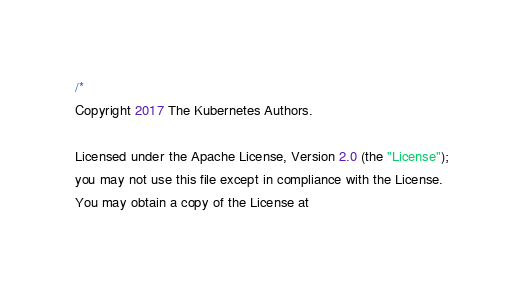<code> <loc_0><loc_0><loc_500><loc_500><_Go_>/*
Copyright 2017 The Kubernetes Authors.

Licensed under the Apache License, Version 2.0 (the "License");
you may not use this file except in compliance with the License.
You may obtain a copy of the License at
</code> 